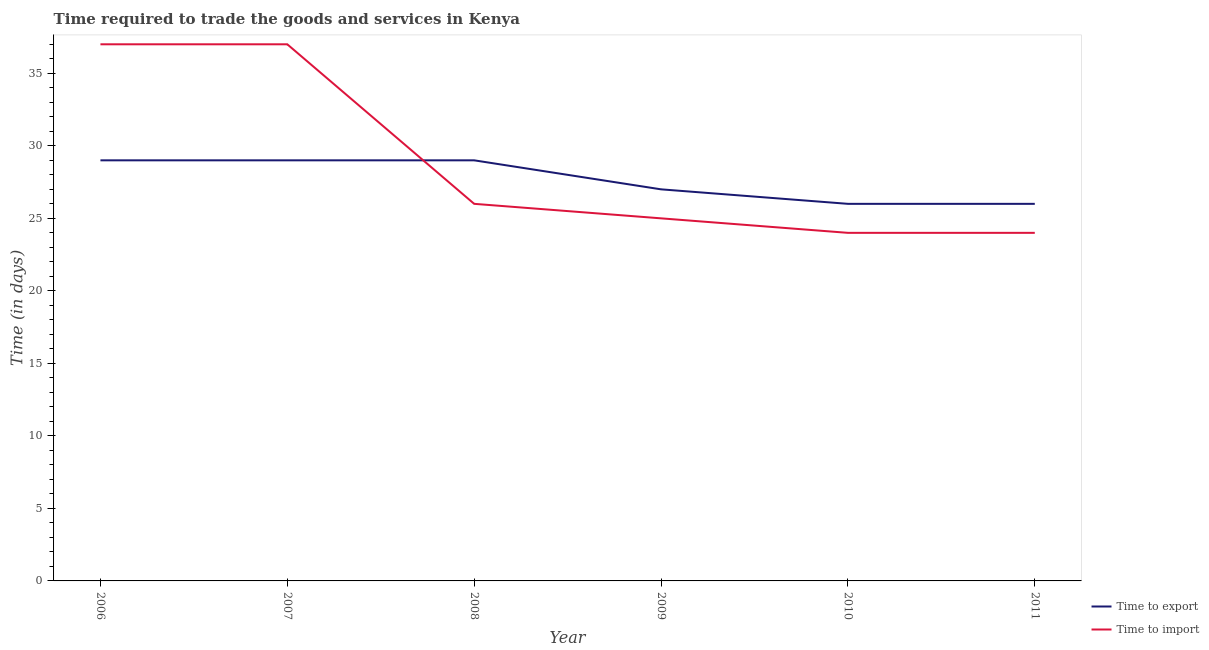What is the time to import in 2011?
Make the answer very short. 24. Across all years, what is the maximum time to export?
Your response must be concise. 29. Across all years, what is the minimum time to export?
Keep it short and to the point. 26. In which year was the time to export minimum?
Your response must be concise. 2010. What is the total time to import in the graph?
Offer a very short reply. 173. What is the difference between the time to import in 2006 and that in 2011?
Ensure brevity in your answer.  13. What is the difference between the time to import in 2006 and the time to export in 2008?
Make the answer very short. 8. What is the average time to import per year?
Your answer should be compact. 28.83. In the year 2009, what is the difference between the time to export and time to import?
Your answer should be compact. 2. In how many years, is the time to import greater than 31 days?
Offer a very short reply. 2. Is the difference between the time to import in 2006 and 2011 greater than the difference between the time to export in 2006 and 2011?
Offer a very short reply. Yes. What is the difference between the highest and the lowest time to import?
Provide a succinct answer. 13. Is the sum of the time to export in 2006 and 2010 greater than the maximum time to import across all years?
Give a very brief answer. Yes. Is the time to import strictly greater than the time to export over the years?
Make the answer very short. No. Is the time to import strictly less than the time to export over the years?
Give a very brief answer. No. What is the difference between two consecutive major ticks on the Y-axis?
Keep it short and to the point. 5. Does the graph contain grids?
Your response must be concise. No. What is the title of the graph?
Your answer should be very brief. Time required to trade the goods and services in Kenya. Does "Working capital" appear as one of the legend labels in the graph?
Your answer should be compact. No. What is the label or title of the Y-axis?
Ensure brevity in your answer.  Time (in days). What is the Time (in days) of Time to export in 2006?
Provide a succinct answer. 29. What is the Time (in days) of Time to import in 2006?
Give a very brief answer. 37. What is the Time (in days) of Time to export in 2007?
Your answer should be very brief. 29. What is the Time (in days) in Time to import in 2007?
Provide a succinct answer. 37. What is the Time (in days) of Time to export in 2008?
Your response must be concise. 29. What is the Time (in days) in Time to export in 2009?
Provide a short and direct response. 27. What is the Time (in days) of Time to import in 2009?
Offer a very short reply. 25. What is the Time (in days) of Time to export in 2011?
Make the answer very short. 26. What is the Time (in days) of Time to import in 2011?
Give a very brief answer. 24. Across all years, what is the maximum Time (in days) in Time to export?
Provide a short and direct response. 29. Across all years, what is the maximum Time (in days) in Time to import?
Your answer should be very brief. 37. What is the total Time (in days) in Time to export in the graph?
Provide a short and direct response. 166. What is the total Time (in days) of Time to import in the graph?
Your answer should be compact. 173. What is the difference between the Time (in days) in Time to export in 2006 and that in 2007?
Offer a terse response. 0. What is the difference between the Time (in days) of Time to import in 2006 and that in 2007?
Your response must be concise. 0. What is the difference between the Time (in days) of Time to export in 2006 and that in 2008?
Your answer should be very brief. 0. What is the difference between the Time (in days) of Time to export in 2006 and that in 2009?
Give a very brief answer. 2. What is the difference between the Time (in days) in Time to import in 2006 and that in 2009?
Make the answer very short. 12. What is the difference between the Time (in days) in Time to import in 2006 and that in 2010?
Provide a succinct answer. 13. What is the difference between the Time (in days) of Time to import in 2006 and that in 2011?
Your answer should be compact. 13. What is the difference between the Time (in days) of Time to import in 2007 and that in 2008?
Your answer should be compact. 11. What is the difference between the Time (in days) in Time to export in 2007 and that in 2009?
Give a very brief answer. 2. What is the difference between the Time (in days) of Time to import in 2007 and that in 2010?
Ensure brevity in your answer.  13. What is the difference between the Time (in days) in Time to export in 2008 and that in 2009?
Your answer should be compact. 2. What is the difference between the Time (in days) of Time to import in 2008 and that in 2009?
Your answer should be compact. 1. What is the difference between the Time (in days) in Time to export in 2008 and that in 2010?
Provide a succinct answer. 3. What is the difference between the Time (in days) in Time to export in 2008 and that in 2011?
Offer a terse response. 3. What is the difference between the Time (in days) of Time to import in 2008 and that in 2011?
Your answer should be very brief. 2. What is the difference between the Time (in days) in Time to import in 2009 and that in 2010?
Offer a very short reply. 1. What is the difference between the Time (in days) of Time to export in 2006 and the Time (in days) of Time to import in 2009?
Your answer should be compact. 4. What is the difference between the Time (in days) in Time to export in 2006 and the Time (in days) in Time to import in 2010?
Give a very brief answer. 5. What is the difference between the Time (in days) in Time to export in 2007 and the Time (in days) in Time to import in 2009?
Make the answer very short. 4. What is the difference between the Time (in days) of Time to export in 2007 and the Time (in days) of Time to import in 2011?
Make the answer very short. 5. What is the difference between the Time (in days) of Time to export in 2008 and the Time (in days) of Time to import in 2009?
Offer a terse response. 4. What is the difference between the Time (in days) of Time to export in 2008 and the Time (in days) of Time to import in 2011?
Provide a short and direct response. 5. What is the difference between the Time (in days) of Time to export in 2009 and the Time (in days) of Time to import in 2010?
Offer a very short reply. 3. What is the difference between the Time (in days) in Time to export in 2010 and the Time (in days) in Time to import in 2011?
Give a very brief answer. 2. What is the average Time (in days) of Time to export per year?
Keep it short and to the point. 27.67. What is the average Time (in days) in Time to import per year?
Offer a terse response. 28.83. In the year 2008, what is the difference between the Time (in days) of Time to export and Time (in days) of Time to import?
Your answer should be very brief. 3. In the year 2009, what is the difference between the Time (in days) of Time to export and Time (in days) of Time to import?
Provide a succinct answer. 2. In the year 2010, what is the difference between the Time (in days) of Time to export and Time (in days) of Time to import?
Offer a very short reply. 2. What is the ratio of the Time (in days) in Time to export in 2006 to that in 2007?
Offer a terse response. 1. What is the ratio of the Time (in days) in Time to import in 2006 to that in 2007?
Ensure brevity in your answer.  1. What is the ratio of the Time (in days) of Time to import in 2006 to that in 2008?
Your answer should be very brief. 1.42. What is the ratio of the Time (in days) in Time to export in 2006 to that in 2009?
Your answer should be very brief. 1.07. What is the ratio of the Time (in days) in Time to import in 2006 to that in 2009?
Provide a short and direct response. 1.48. What is the ratio of the Time (in days) in Time to export in 2006 to that in 2010?
Provide a short and direct response. 1.12. What is the ratio of the Time (in days) of Time to import in 2006 to that in 2010?
Offer a very short reply. 1.54. What is the ratio of the Time (in days) of Time to export in 2006 to that in 2011?
Your response must be concise. 1.12. What is the ratio of the Time (in days) in Time to import in 2006 to that in 2011?
Give a very brief answer. 1.54. What is the ratio of the Time (in days) in Time to export in 2007 to that in 2008?
Provide a succinct answer. 1. What is the ratio of the Time (in days) in Time to import in 2007 to that in 2008?
Provide a short and direct response. 1.42. What is the ratio of the Time (in days) in Time to export in 2007 to that in 2009?
Keep it short and to the point. 1.07. What is the ratio of the Time (in days) in Time to import in 2007 to that in 2009?
Ensure brevity in your answer.  1.48. What is the ratio of the Time (in days) in Time to export in 2007 to that in 2010?
Offer a terse response. 1.12. What is the ratio of the Time (in days) of Time to import in 2007 to that in 2010?
Provide a succinct answer. 1.54. What is the ratio of the Time (in days) of Time to export in 2007 to that in 2011?
Keep it short and to the point. 1.12. What is the ratio of the Time (in days) of Time to import in 2007 to that in 2011?
Provide a short and direct response. 1.54. What is the ratio of the Time (in days) in Time to export in 2008 to that in 2009?
Offer a terse response. 1.07. What is the ratio of the Time (in days) of Time to export in 2008 to that in 2010?
Your answer should be very brief. 1.12. What is the ratio of the Time (in days) of Time to export in 2008 to that in 2011?
Ensure brevity in your answer.  1.12. What is the ratio of the Time (in days) in Time to import in 2008 to that in 2011?
Offer a terse response. 1.08. What is the ratio of the Time (in days) of Time to import in 2009 to that in 2010?
Provide a succinct answer. 1.04. What is the ratio of the Time (in days) in Time to export in 2009 to that in 2011?
Provide a succinct answer. 1.04. What is the ratio of the Time (in days) in Time to import in 2009 to that in 2011?
Keep it short and to the point. 1.04. What is the ratio of the Time (in days) in Time to export in 2010 to that in 2011?
Your answer should be very brief. 1. What is the difference between the highest and the second highest Time (in days) of Time to export?
Make the answer very short. 0. What is the difference between the highest and the second highest Time (in days) of Time to import?
Provide a succinct answer. 0. What is the difference between the highest and the lowest Time (in days) of Time to export?
Your answer should be very brief. 3. What is the difference between the highest and the lowest Time (in days) in Time to import?
Offer a terse response. 13. 